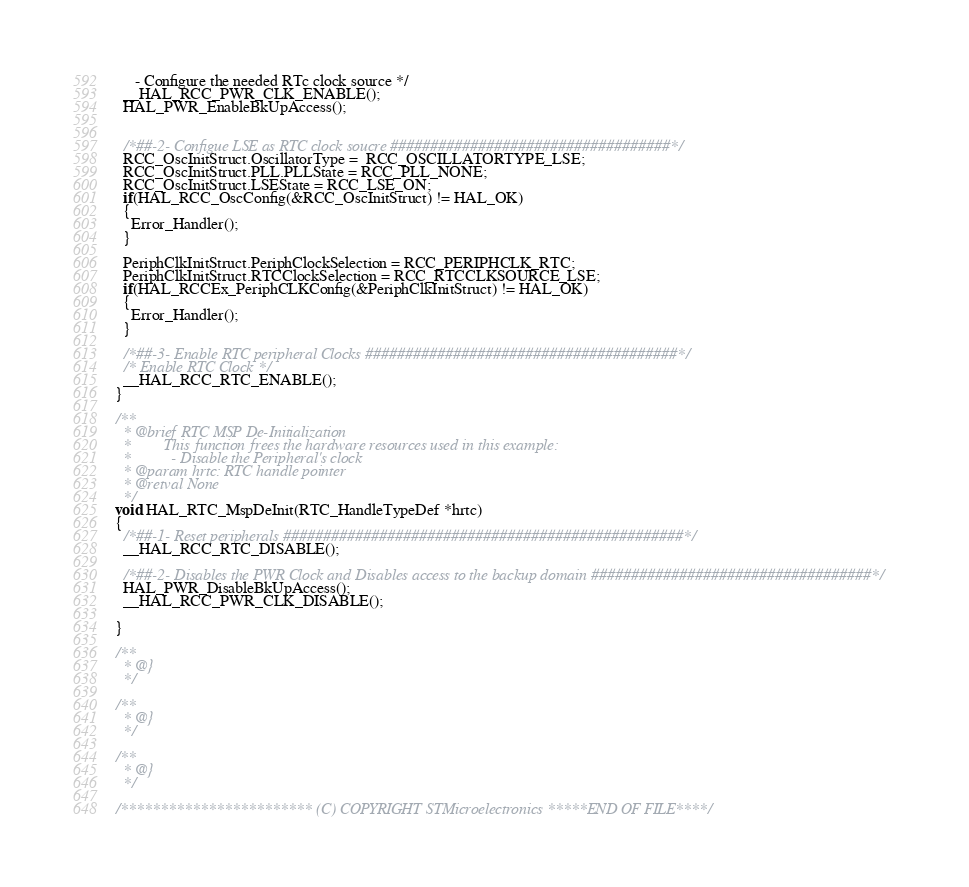<code> <loc_0><loc_0><loc_500><loc_500><_C_>     - Configure the needed RTc clock source */
  __HAL_RCC_PWR_CLK_ENABLE();
  HAL_PWR_EnableBkUpAccess();

  
  /*##-2- Configue LSE as RTC clock soucre ###################################*/
  RCC_OscInitStruct.OscillatorType =  RCC_OSCILLATORTYPE_LSE;
  RCC_OscInitStruct.PLL.PLLState = RCC_PLL_NONE;
  RCC_OscInitStruct.LSEState = RCC_LSE_ON;
  if(HAL_RCC_OscConfig(&RCC_OscInitStruct) != HAL_OK)
  { 
    Error_Handler();
  }
  
  PeriphClkInitStruct.PeriphClockSelection = RCC_PERIPHCLK_RTC;
  PeriphClkInitStruct.RTCClockSelection = RCC_RTCCLKSOURCE_LSE;
  if(HAL_RCCEx_PeriphCLKConfig(&PeriphClkInitStruct) != HAL_OK)
  { 
    Error_Handler();
  }
  
  /*##-3- Enable RTC peripheral Clocks #######################################*/
  /* Enable RTC Clock */
  __HAL_RCC_RTC_ENABLE();
}

/**
  * @brief RTC MSP De-Initialization
  *        This function frees the hardware resources used in this example:
  *          - Disable the Peripheral's clock
  * @param hrtc: RTC handle pointer
  * @retval None
  */
void HAL_RTC_MspDeInit(RTC_HandleTypeDef *hrtc)
{
  /*##-1- Reset peripherals ##################################################*/
  __HAL_RCC_RTC_DISABLE();

  /*##-2- Disables the PWR Clock and Disables access to the backup domain ###################################*/
  HAL_PWR_DisableBkUpAccess();
  __HAL_RCC_PWR_CLK_DISABLE();
  
}

/**
  * @}
  */

/**
  * @}
  */

/**
  * @}
  */

/************************ (C) COPYRIGHT STMicroelectronics *****END OF FILE****/
</code> 